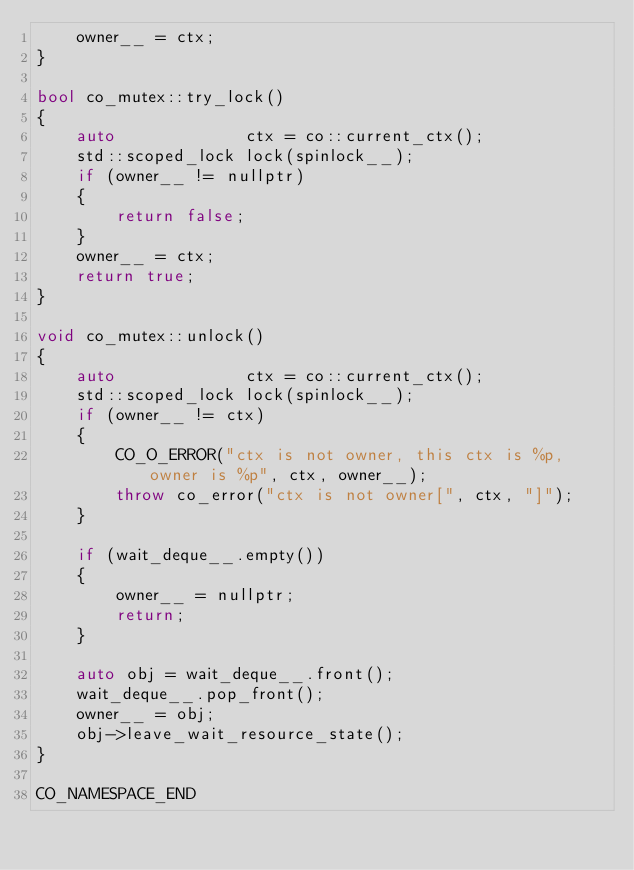<code> <loc_0><loc_0><loc_500><loc_500><_C++_>    owner__ = ctx;
}

bool co_mutex::try_lock()
{
    auto             ctx = co::current_ctx();
    std::scoped_lock lock(spinlock__);
    if (owner__ != nullptr)
    {
        return false;
    }
    owner__ = ctx;
    return true;
}

void co_mutex::unlock()
{
    auto             ctx = co::current_ctx();
    std::scoped_lock lock(spinlock__);
    if (owner__ != ctx)
    {
        CO_O_ERROR("ctx is not owner, this ctx is %p, owner is %p", ctx, owner__);
        throw co_error("ctx is not owner[", ctx, "]");
    }

    if (wait_deque__.empty())
    {
        owner__ = nullptr;
        return;
    }

    auto obj = wait_deque__.front();
    wait_deque__.pop_front();
    owner__ = obj;
    obj->leave_wait_resource_state();
}

CO_NAMESPACE_END</code> 